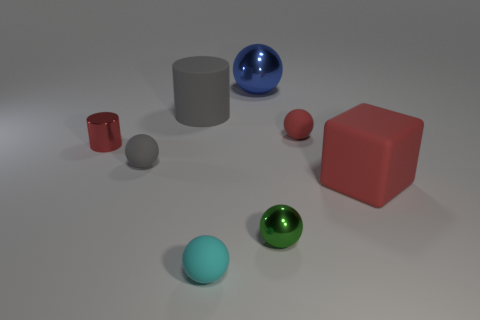Subtract all green balls. How many balls are left? 4 Add 1 big cyan rubber balls. How many objects exist? 9 Subtract all red balls. How many balls are left? 4 Subtract 2 balls. How many balls are left? 3 Subtract all cylinders. How many objects are left? 6 Add 1 small gray matte blocks. How many small gray matte blocks exist? 1 Subtract 0 blue cubes. How many objects are left? 8 Subtract all purple cylinders. Subtract all purple cubes. How many cylinders are left? 2 Subtract all gray matte spheres. Subtract all large blue spheres. How many objects are left? 6 Add 2 cylinders. How many cylinders are left? 4 